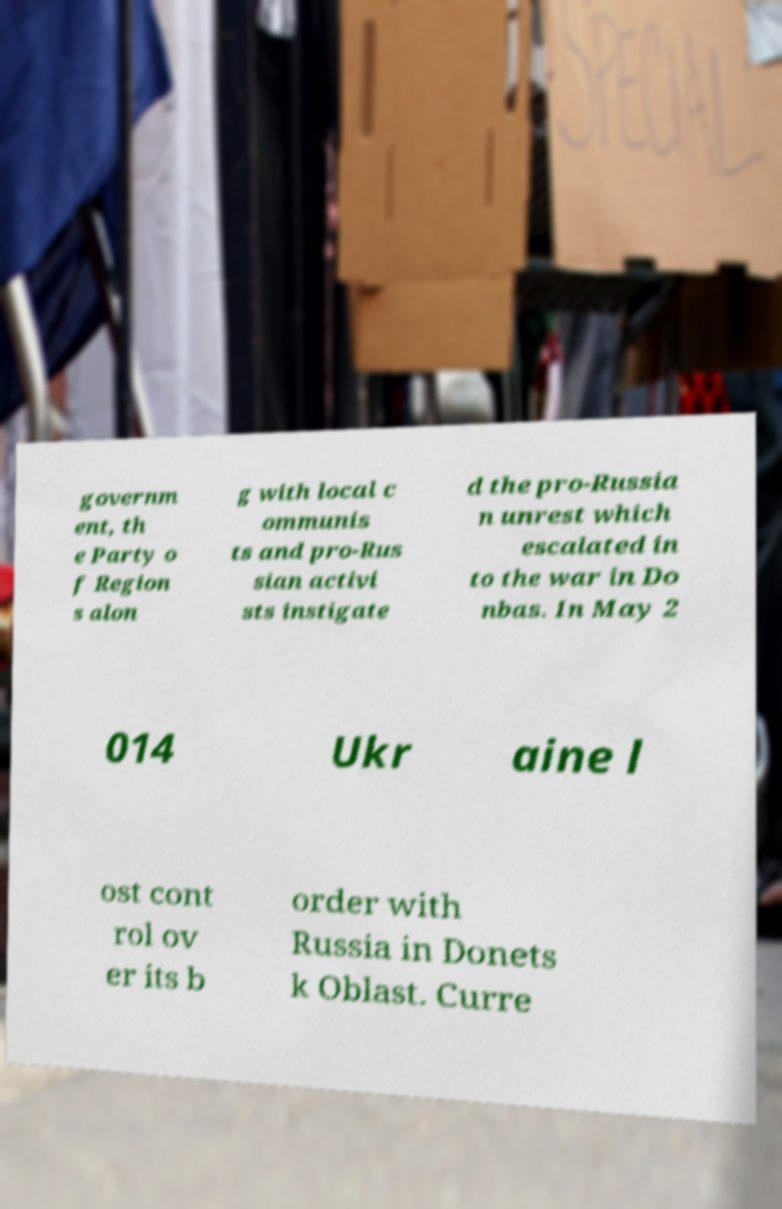I need the written content from this picture converted into text. Can you do that? governm ent, th e Party o f Region s alon g with local c ommunis ts and pro-Rus sian activi sts instigate d the pro-Russia n unrest which escalated in to the war in Do nbas. In May 2 014 Ukr aine l ost cont rol ov er its b order with Russia in Donets k Oblast. Curre 